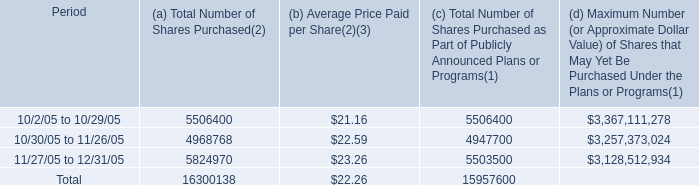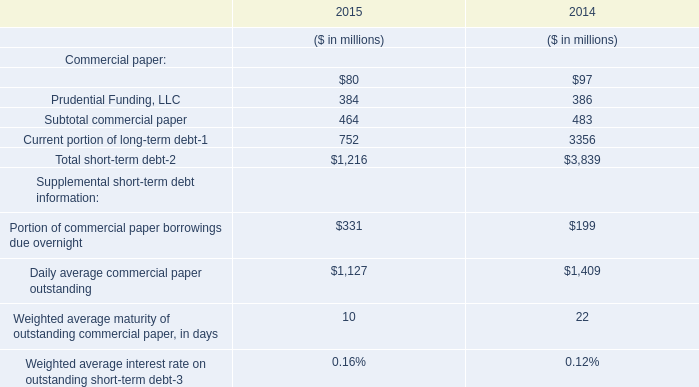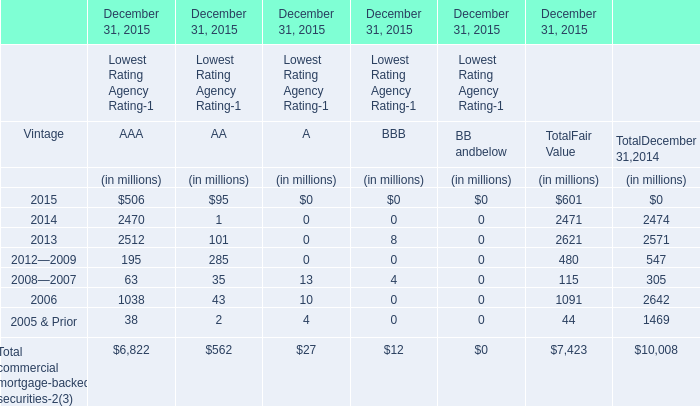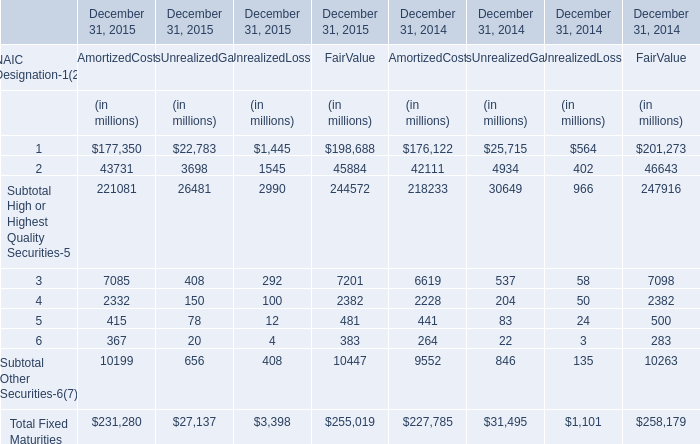What is the ratio of 5 to the total in 2015 for AmortizedCost? 
Computations: (415 / 231280)
Answer: 0.00179. 